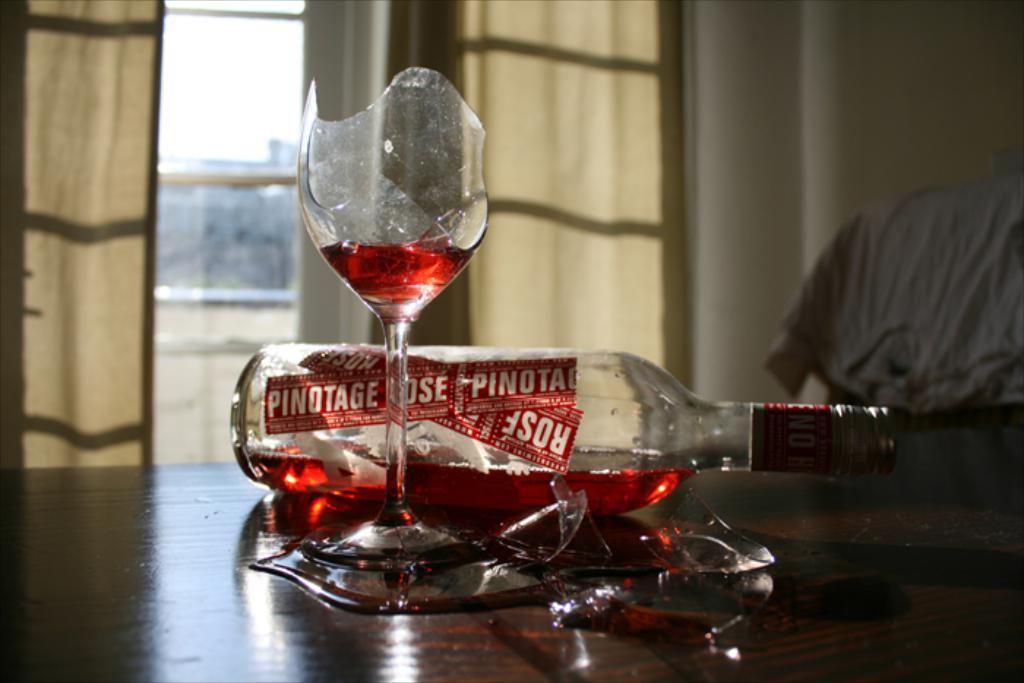In one or two sentences, can you explain what this image depicts? On this wooden surface there is a bottle and glass. Background it is blur. We can see curtains and cloth. 